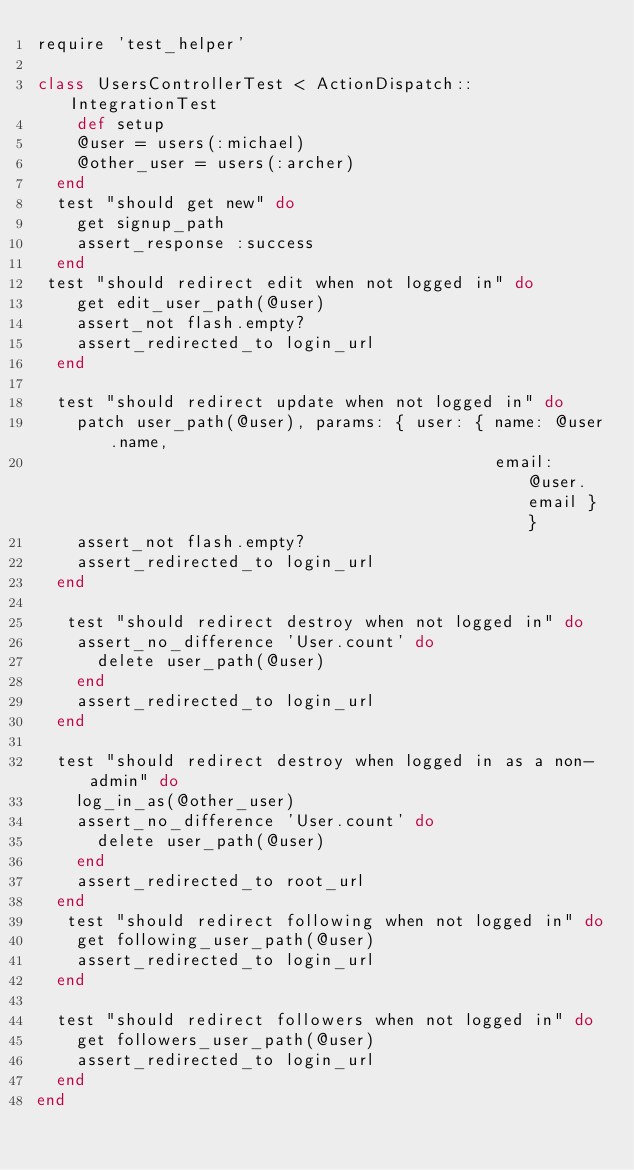Convert code to text. <code><loc_0><loc_0><loc_500><loc_500><_Ruby_>require 'test_helper'

class UsersControllerTest < ActionDispatch::IntegrationTest
	def setup
    @user = users(:michael)
    @other_user = users(:archer)
  end
  test "should get new" do
    get signup_path
    assert_response :success
  end
 test "should redirect edit when not logged in" do
    get edit_user_path(@user)
    assert_not flash.empty?
    assert_redirected_to login_url
  end

  test "should redirect update when not logged in" do
    patch user_path(@user), params: { user: { name: @user.name,
                                              email: @user.email } }
    assert_not flash.empty?
    assert_redirected_to login_url
  end

   test "should redirect destroy when not logged in" do
    assert_no_difference 'User.count' do
      delete user_path(@user)
    end
    assert_redirected_to login_url
  end

  test "should redirect destroy when logged in as a non-admin" do
    log_in_as(@other_user)
    assert_no_difference 'User.count' do
      delete user_path(@user)
    end
    assert_redirected_to root_url
  end
   test "should redirect following when not logged in" do
    get following_user_path(@user)
    assert_redirected_to login_url
  end

  test "should redirect followers when not logged in" do
    get followers_user_path(@user)
    assert_redirected_to login_url
  end
end
</code> 